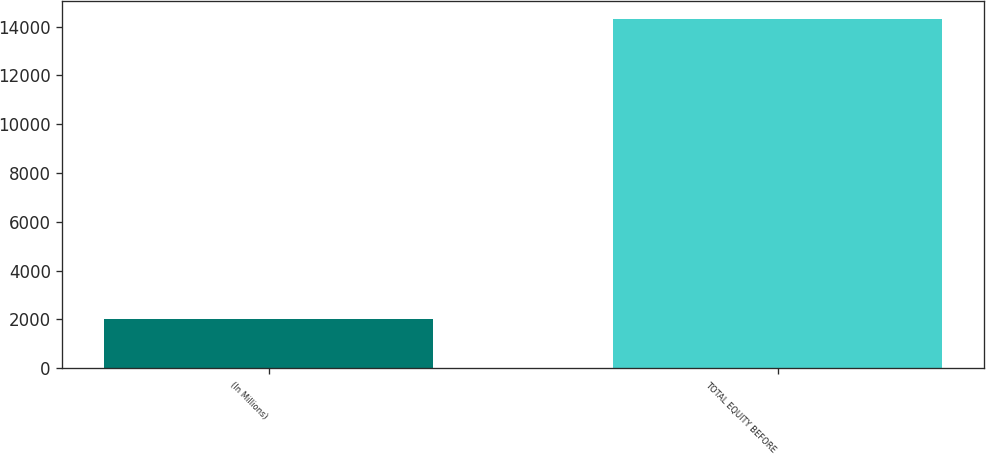<chart> <loc_0><loc_0><loc_500><loc_500><bar_chart><fcel>(In Millions)<fcel>TOTAL EQUITY BEFORE<nl><fcel>2016<fcel>14325<nl></chart> 